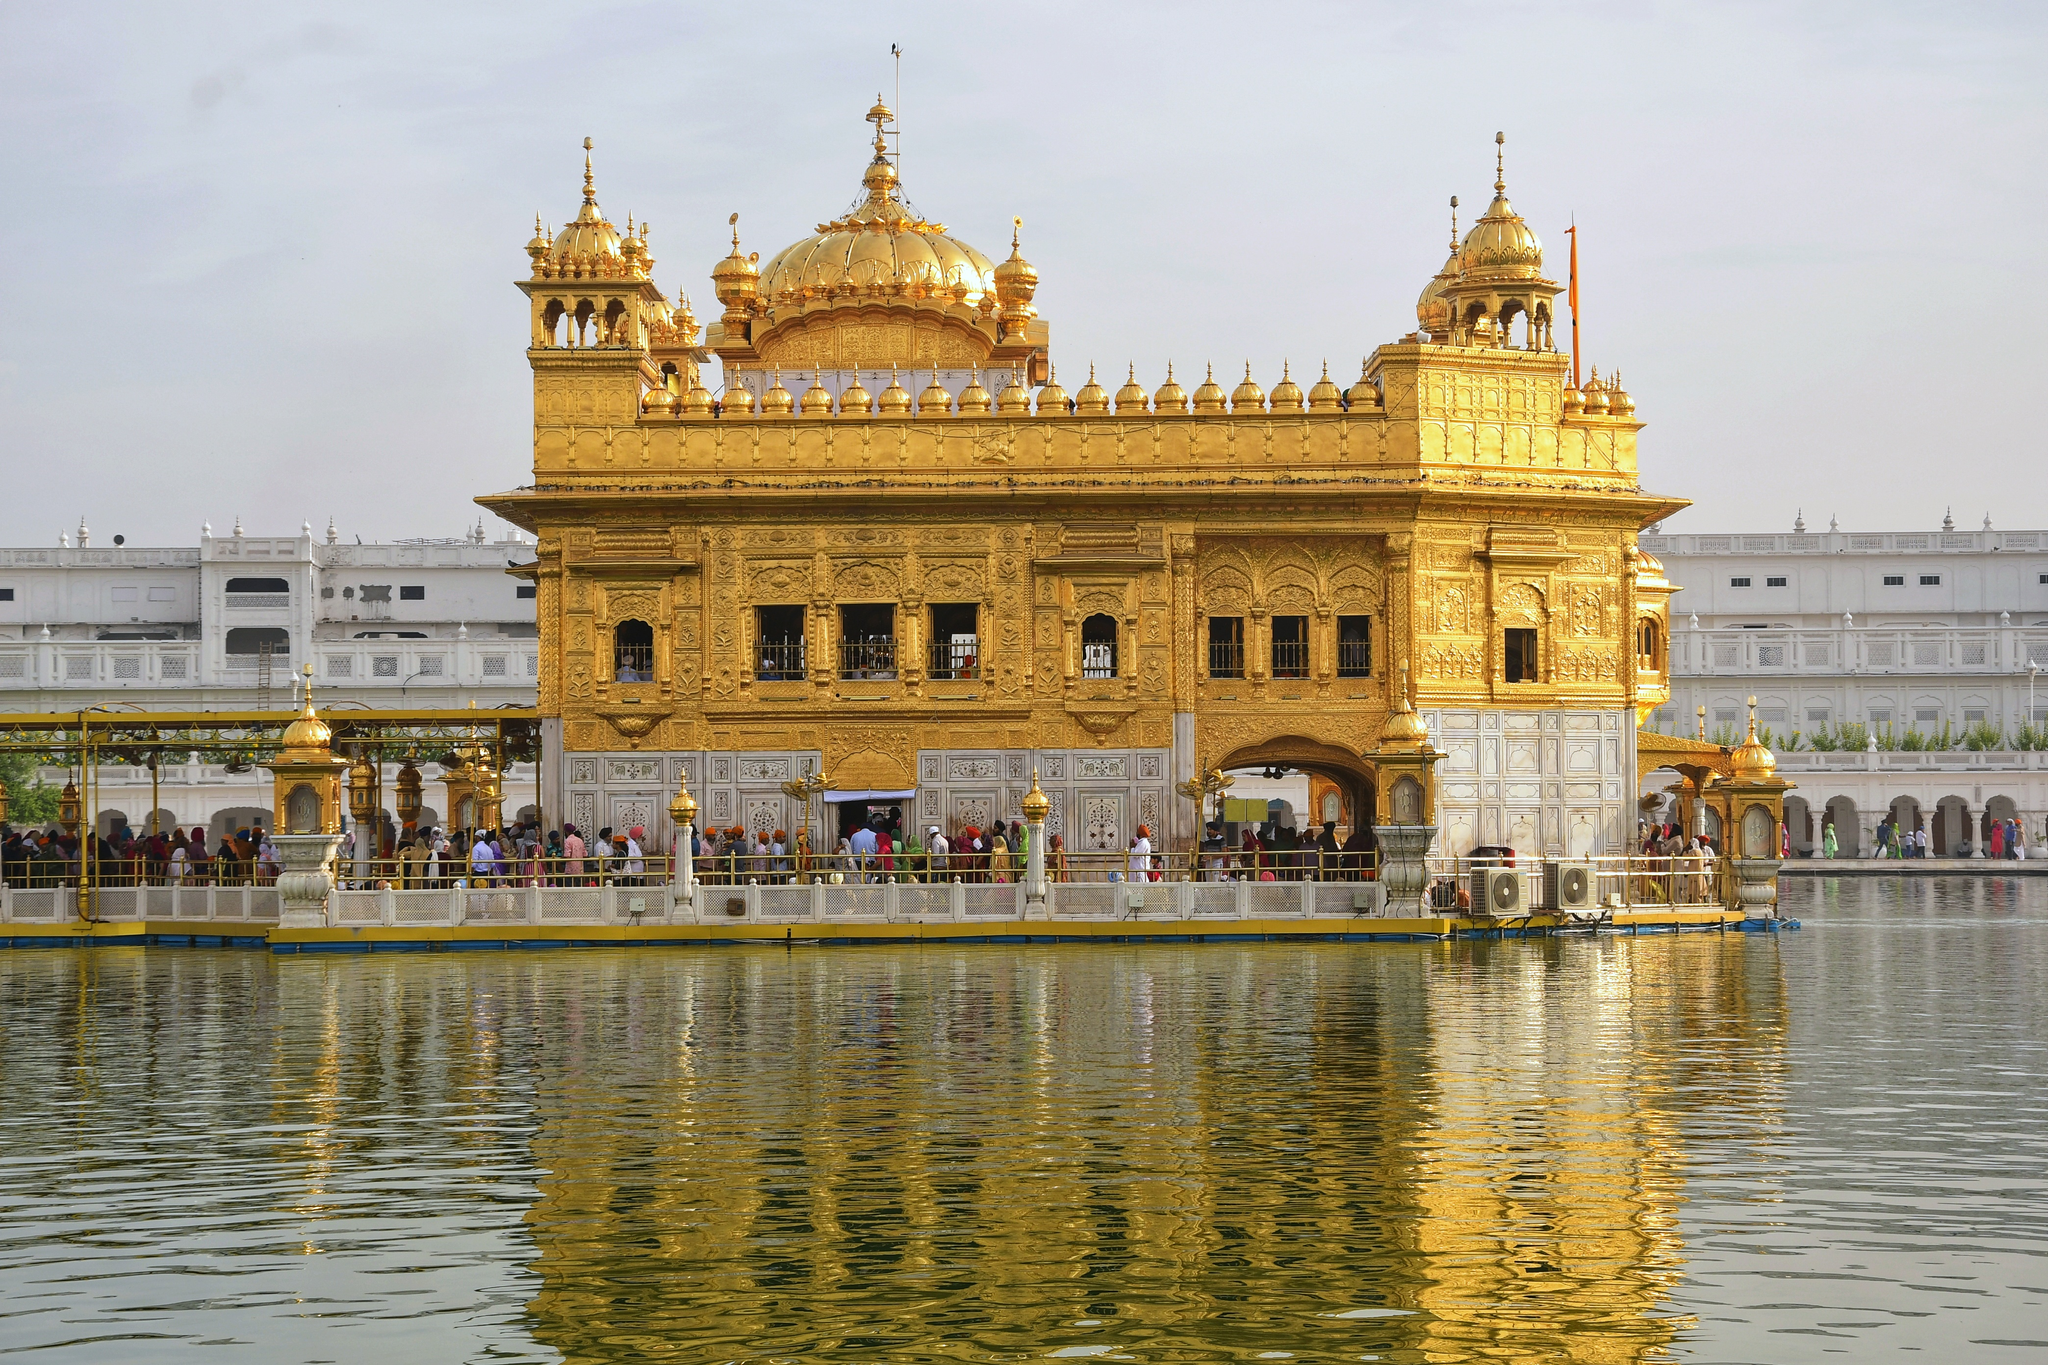Can you explain the architectural significance of the Golden Temple? Certainly! The Golden Temple exemplifies a unique blend of Hindu and Islamic architectural styles, known as Indo-Islamic architecture, which was prevalent during the 16th century in India. Its main shrine is adorned with intricate gold panels and is topped with a gilded dome shaped similarly to an inverted lotus, symbolizing purity and enlightenment. The surrounding structures are constructed using pristine white marble, adorned with detailed pietra dura inlays, displaying floral and geometric patterns that add to its aesthetic and spiritual allure. The architecture not only serves an aesthetic purpose but is also functional, accommodating thousands of visitors daily, ensuring a flow that supports both the spiritual ambiance and visitor logistics. 